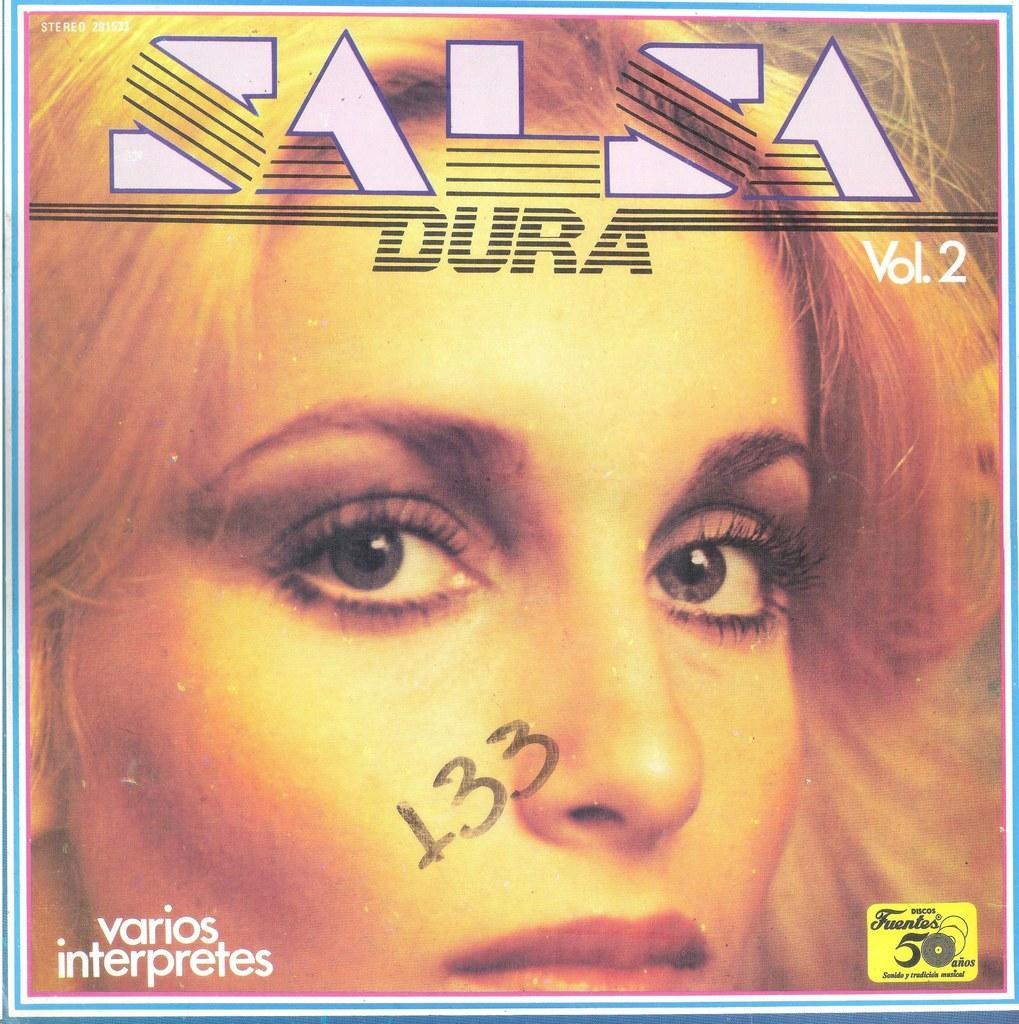<image>
Give a short and clear explanation of the subsequent image. The cover of an album with the number 133 written on it 